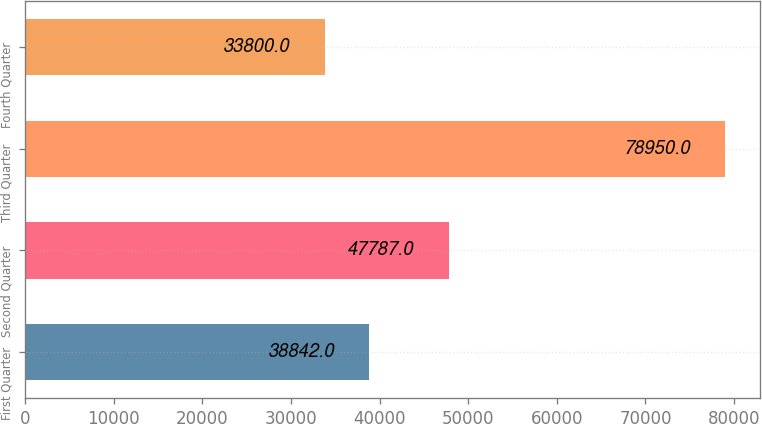Convert chart to OTSL. <chart><loc_0><loc_0><loc_500><loc_500><bar_chart><fcel>First Quarter<fcel>Second Quarter<fcel>Third Quarter<fcel>Fourth Quarter<nl><fcel>38842<fcel>47787<fcel>78950<fcel>33800<nl></chart> 